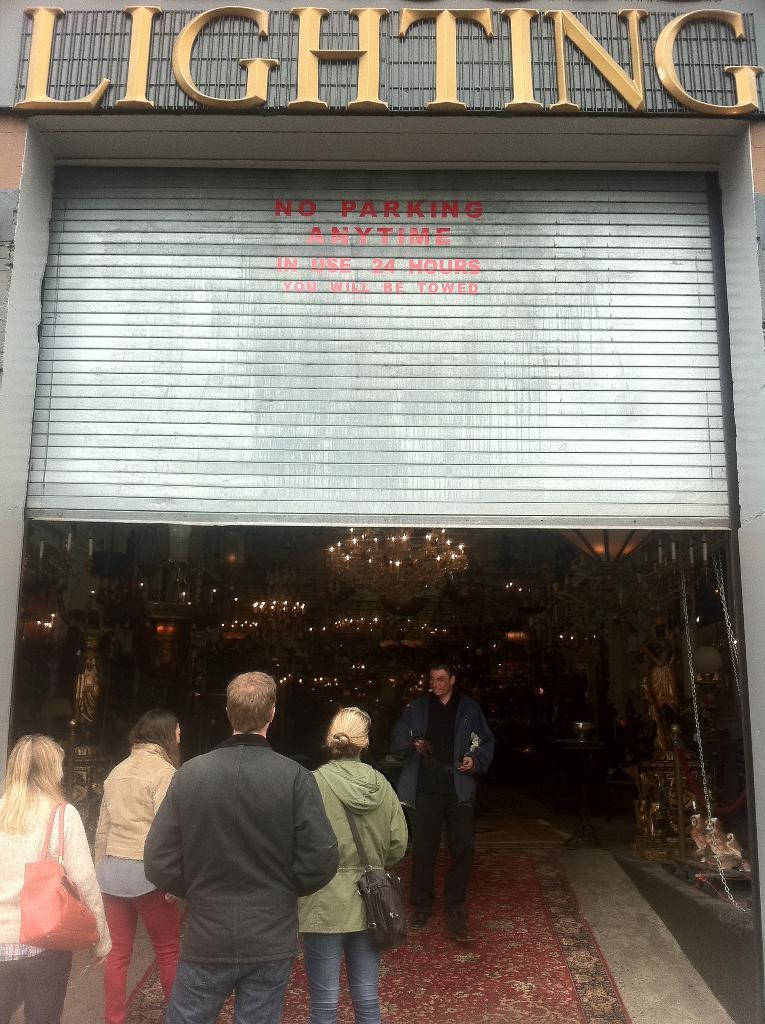What are the people in the image doing? The people in the image are walking. What are the two people wearing that are visible in the image? The two people are wearing bags. Can you describe the metal object with text in the image? Yes, it has text on it. What type of lighting fixture can be seen in the background of the image? Chandeliers are visible in the background. How would you describe the lighting in the image? The image appears to be dark. What type of seafood is being cooked by the cook in the image? There is no cook or seafood present in the image. What type of act is being performed by the people in the image? The people in the image are simply walking, and there is no act being performed. 